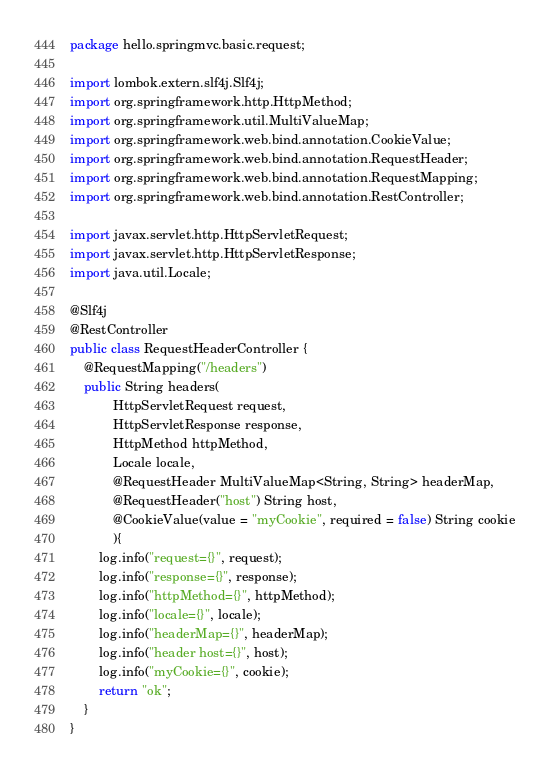<code> <loc_0><loc_0><loc_500><loc_500><_Java_>package hello.springmvc.basic.request;

import lombok.extern.slf4j.Slf4j;
import org.springframework.http.HttpMethod;
import org.springframework.util.MultiValueMap;
import org.springframework.web.bind.annotation.CookieValue;
import org.springframework.web.bind.annotation.RequestHeader;
import org.springframework.web.bind.annotation.RequestMapping;
import org.springframework.web.bind.annotation.RestController;

import javax.servlet.http.HttpServletRequest;
import javax.servlet.http.HttpServletResponse;
import java.util.Locale;

@Slf4j
@RestController
public class RequestHeaderController {
    @RequestMapping("/headers")
    public String headers(
            HttpServletRequest request,
            HttpServletResponse response,
            HttpMethod httpMethod,
            Locale locale,
            @RequestHeader MultiValueMap<String, String> headerMap,
            @RequestHeader("host") String host,
            @CookieValue(value = "myCookie", required = false) String cookie
            ){
        log.info("request={}", request);
        log.info("response={}", response);
        log.info("httpMethod={}", httpMethod);
        log.info("locale={}", locale);
        log.info("headerMap={}", headerMap);
        log.info("header host={}", host);
        log.info("myCookie={}", cookie);
        return "ok";
    }
}
</code> 